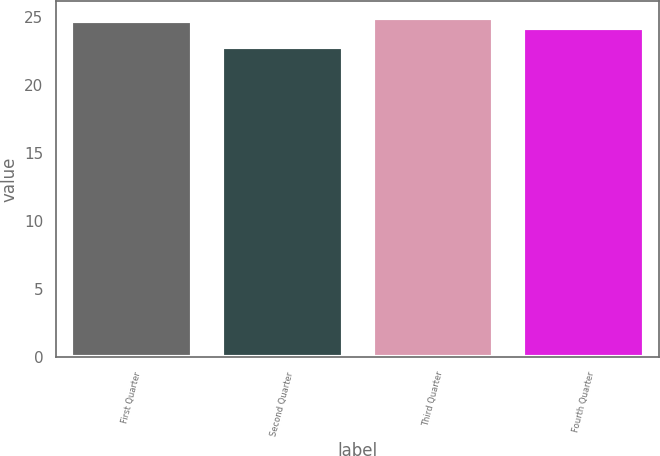<chart> <loc_0><loc_0><loc_500><loc_500><bar_chart><fcel>First Quarter<fcel>Second Quarter<fcel>Third Quarter<fcel>Fourth Quarter<nl><fcel>24.75<fcel>22.79<fcel>24.96<fcel>24.19<nl></chart> 